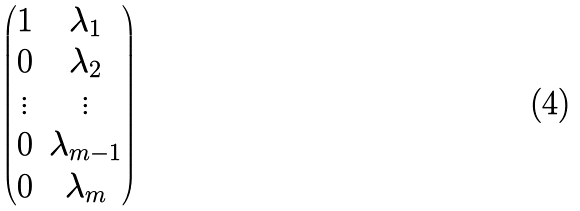<formula> <loc_0><loc_0><loc_500><loc_500>\begin{pmatrix} 1 & \lambda _ { 1 } \\ 0 & \lambda _ { 2 } \\ \vdots & \vdots \\ 0 & \lambda _ { m - 1 } \\ 0 & \lambda _ { m } \end{pmatrix}</formula> 